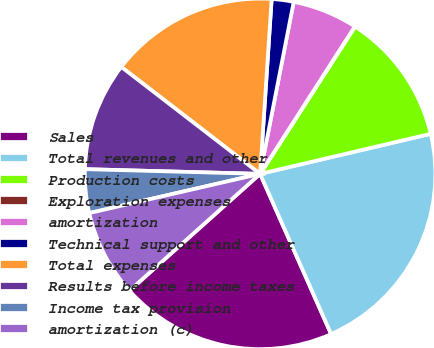Convert chart to OTSL. <chart><loc_0><loc_0><loc_500><loc_500><pie_chart><fcel>Sales<fcel>Total revenues and other<fcel>Production costs<fcel>Exploration expenses<fcel>amortization<fcel>Technical support and other<fcel>Total expenses<fcel>Results before income taxes<fcel>Income tax provision<fcel>amortization (c)<nl><fcel>20.03%<fcel>22.03%<fcel>12.22%<fcel>0.02%<fcel>6.02%<fcel>2.02%<fcel>15.6%<fcel>10.02%<fcel>4.02%<fcel>8.02%<nl></chart> 